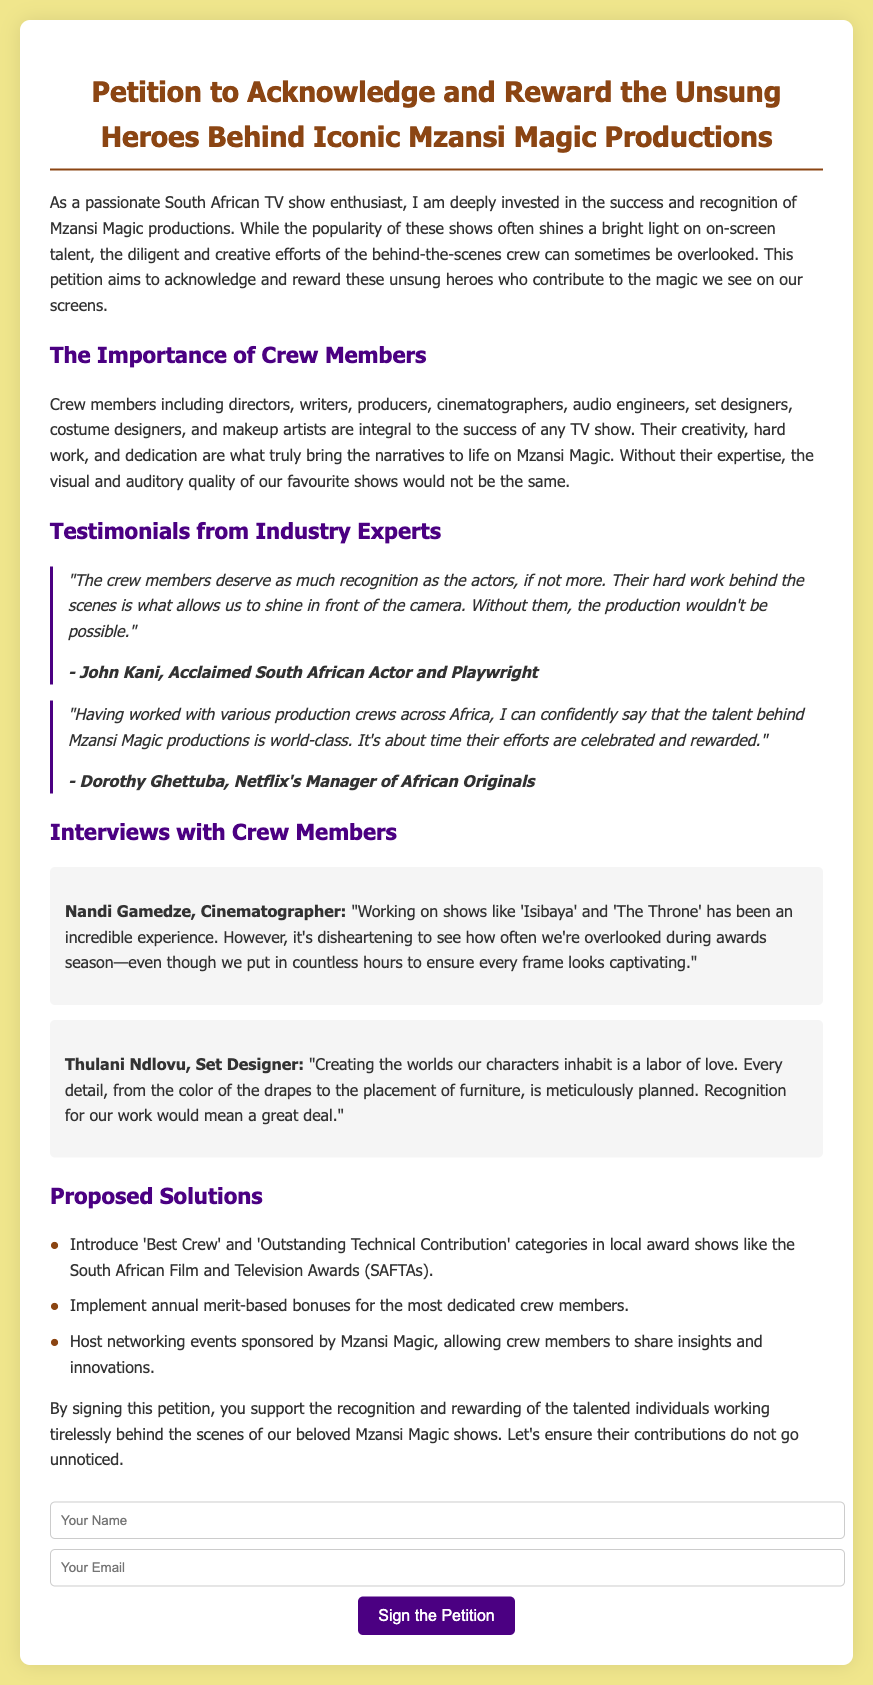what is the title of the petition? The title of the petition is prominently displayed at the top of the document.
Answer: Petition to Acknowledge and Reward the Unsung Heroes Behind Iconic Mzansi Magic Productions who is the acclaimed South African actor mentioned? John Kani's testimonial is included in the document as an acclaimed actor and playwright.
Answer: John Kani what are the proposed solutions for recognizing crew members? The document lists specific proposals in a bulleted format regarding crew recognition.
Answer: Introduce 'Best Crew' and 'Outstanding Technical Contribution' categories in local award shows how many interviews with crew members are included? The document features a section specifically for crew member interviews which includes these contributions.
Answer: Two who is Netflix's Manager of African Originals quoted in the document? The document attributes a quote to a specific individual associated with Netflix, aiding in industry credibility.
Answer: Dorothy Ghettuba what role does Nandi Gamedze serve in the crew? Nandi Gamedze is identified by her position in the crew, showcasing a specific talent in the industry.
Answer: Cinematographer what is the background color of the document? The background color is mentioned in the style section of the document, which affects its visual appeal.
Answer: Light yellow how can individuals show support for the petition? The document provides a clear call to action for showing support through a specific method.
Answer: By signing the petition what is the purpose of this petition? The petition explicitly states its aim in the introductory paragraph, summarizing its main goal.
Answer: Acknowledge and reward the unsung heroes behind Mzansi Magic productions 